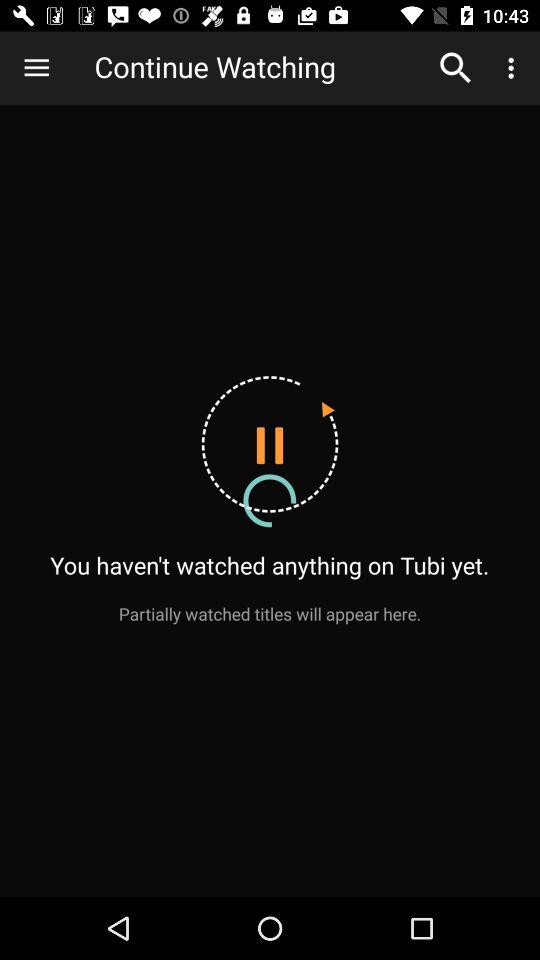What is the name of the application? The name of the application is "Tubi". 